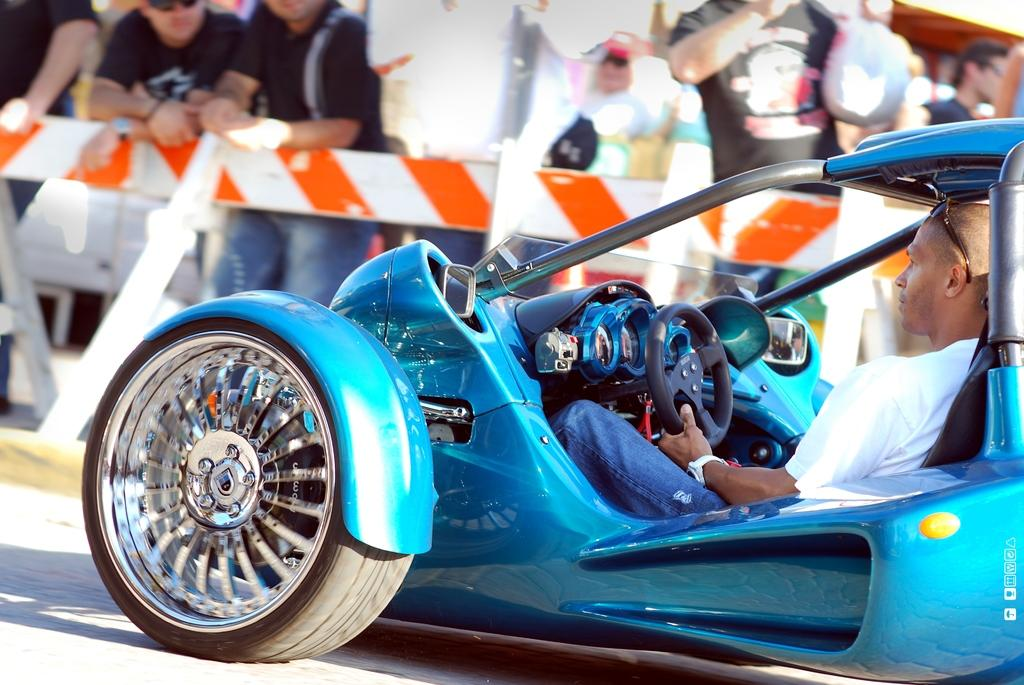Who is the main subject in the image? There is a man in the image. What is the man doing in the image? The man is riding a car. Can you describe the car in the image? The car is blue in color and is on the road. What can be seen in the background of the image? There are people standing in the background of the image. What type of skate is the boy using in the image? There is no boy or skate present in the image. What is being exchanged between the people in the background of the image? There is no exchange happening between the people in the background of the image. 